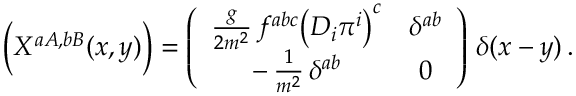Convert formula to latex. <formula><loc_0><loc_0><loc_500><loc_500>\left ( X ^ { a A , b B } ( x , y ) \right ) = \left ( \begin{array} { c c } { { \frac { g } { 2 m ^ { 2 } } \, f ^ { a b c } \left ( D _ { i } \pi ^ { i } \right ) ^ { c } } } & { { \delta ^ { a b } } } \\ { { - \, \frac { 1 } { m ^ { 2 } } \, \delta ^ { a b } } } & { 0 } \end{array} \right ) \, \delta ( x - y ) \, .</formula> 